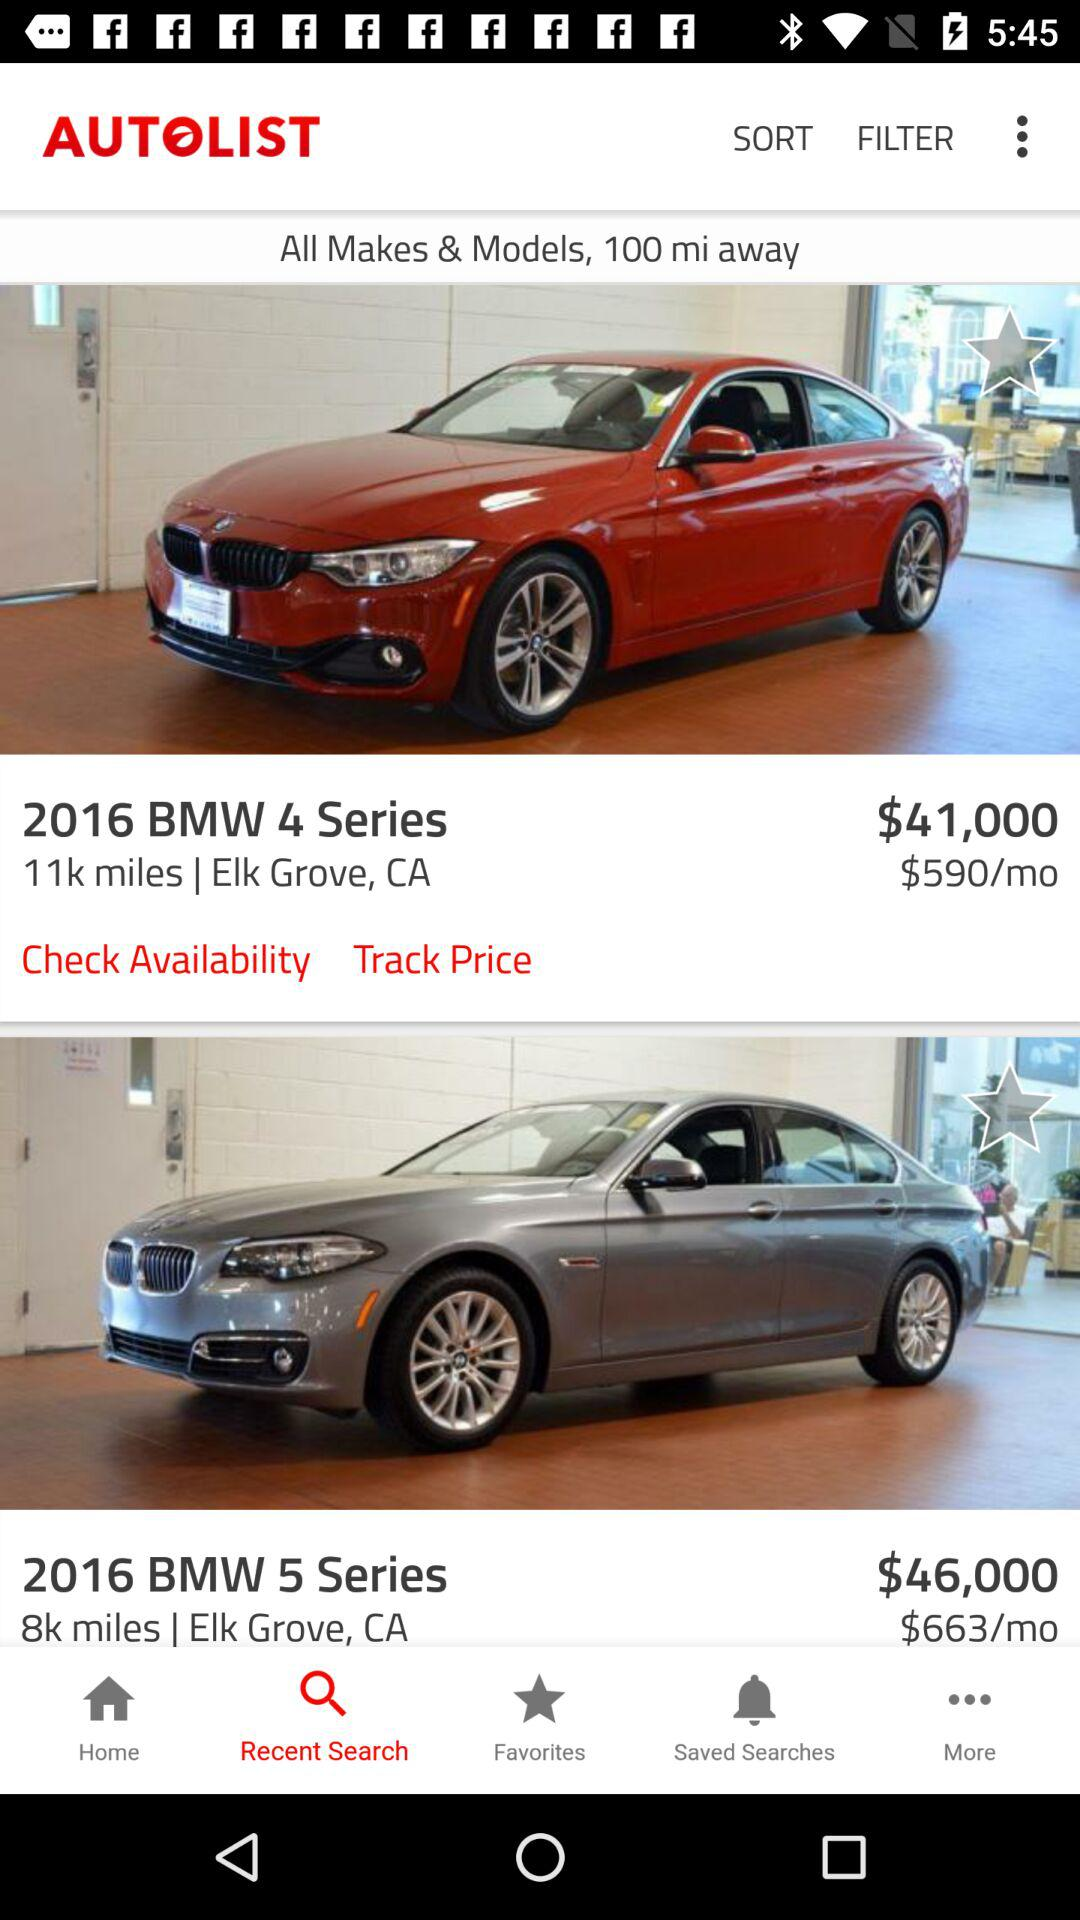How much more does the BMW 5 Series cost than the BMW 4 Series?
Answer the question using a single word or phrase. $5,000 